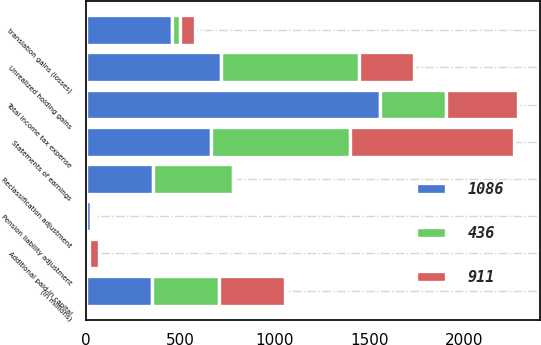<chart> <loc_0><loc_0><loc_500><loc_500><stacked_bar_chart><ecel><fcel>(In millions)<fcel>Statements of earnings<fcel>translation gains (losses)<fcel>Unrealized holding gains<fcel>Reclassification adjustment<fcel>Pension liability adjustment<fcel>Total income tax expense<fcel>Additional paid-in capital<nl><fcel>436<fcel>351<fcel>738<fcel>39<fcel>728<fcel>424<fcel>8<fcel>351<fcel>3<nl><fcel>1086<fcel>351<fcel>660<fcel>457<fcel>716<fcel>353<fcel>29<fcel>1555<fcel>16<nl><fcel>911<fcel>351<fcel>865<fcel>82<fcel>291<fcel>10<fcel>5<fcel>378<fcel>51<nl></chart> 